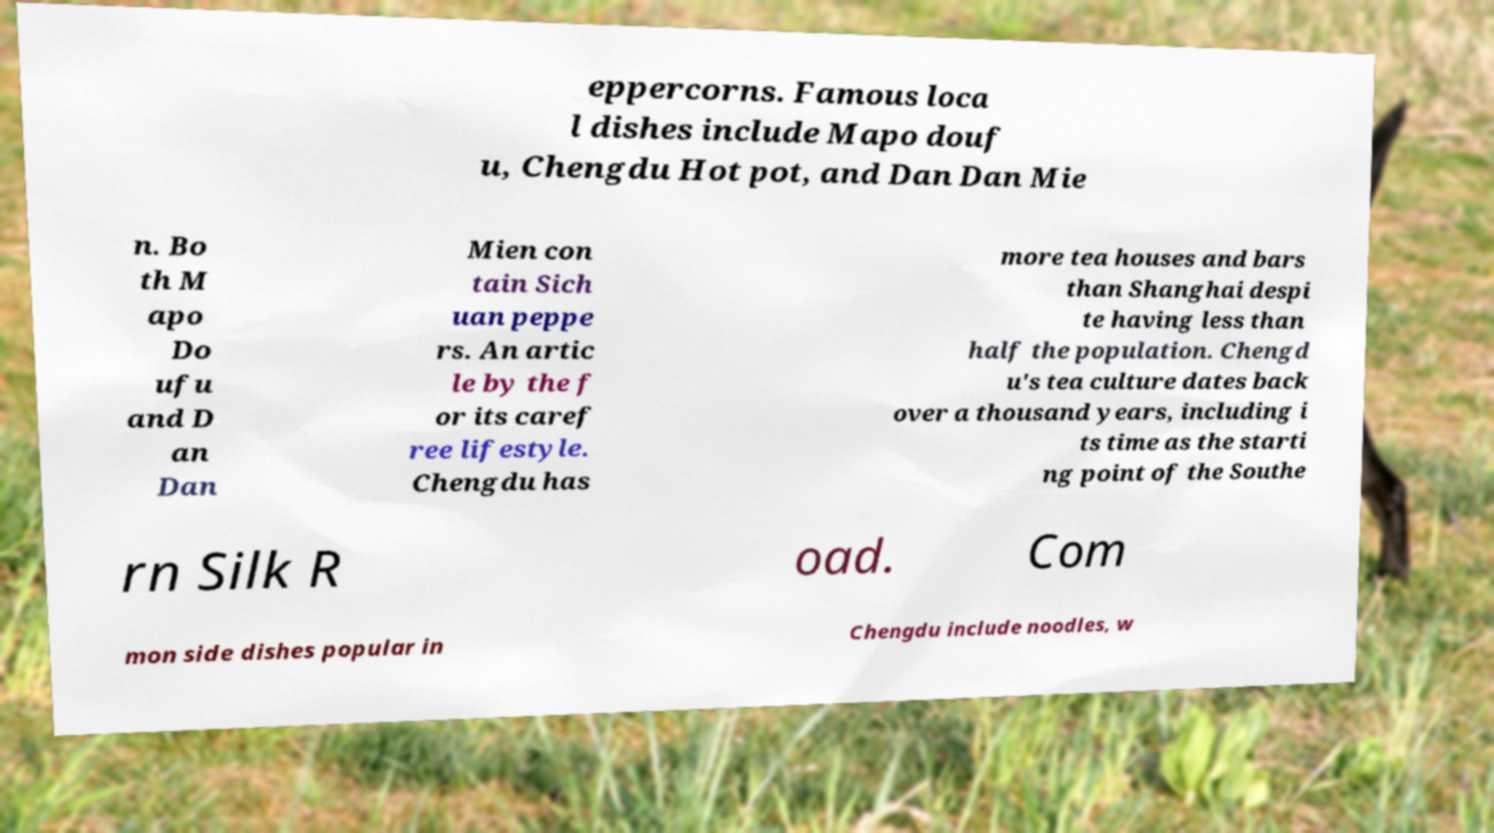There's text embedded in this image that I need extracted. Can you transcribe it verbatim? eppercorns. Famous loca l dishes include Mapo douf u, Chengdu Hot pot, and Dan Dan Mie n. Bo th M apo Do ufu and D an Dan Mien con tain Sich uan peppe rs. An artic le by the f or its caref ree lifestyle. Chengdu has more tea houses and bars than Shanghai despi te having less than half the population. Chengd u's tea culture dates back over a thousand years, including i ts time as the starti ng point of the Southe rn Silk R oad. Com mon side dishes popular in Chengdu include noodles, w 